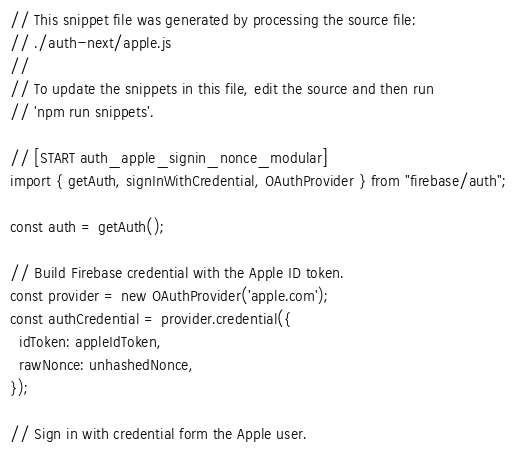<code> <loc_0><loc_0><loc_500><loc_500><_JavaScript_>// This snippet file was generated by processing the source file:
// ./auth-next/apple.js
//
// To update the snippets in this file, edit the source and then run
// 'npm run snippets'.

// [START auth_apple_signin_nonce_modular]
import { getAuth, signInWithCredential, OAuthProvider } from "firebase/auth";

const auth = getAuth();

// Build Firebase credential with the Apple ID token.
const provider = new OAuthProvider('apple.com');
const authCredential = provider.credential({
  idToken: appleIdToken,
  rawNonce: unhashedNonce,
});

// Sign in with credential form the Apple user.</code> 